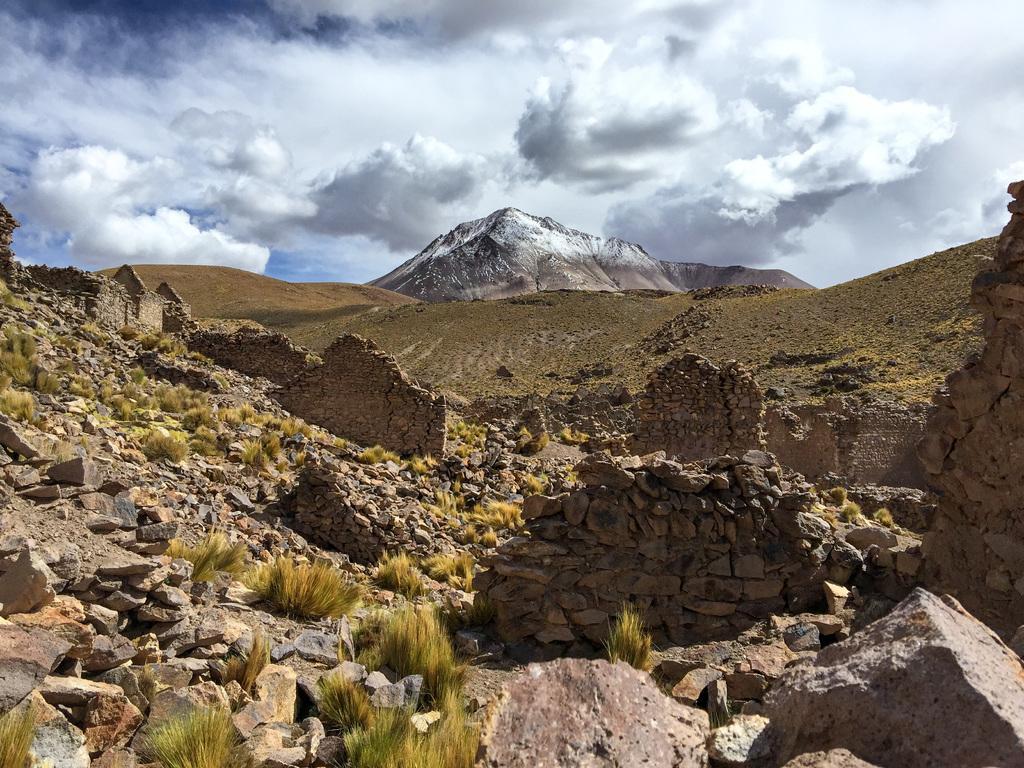In one or two sentences, can you explain what this image depicts? In this image there are few rocks and grass are on the land. Middle of the image there are few hills. Top of the image there is sky with some clouds. 